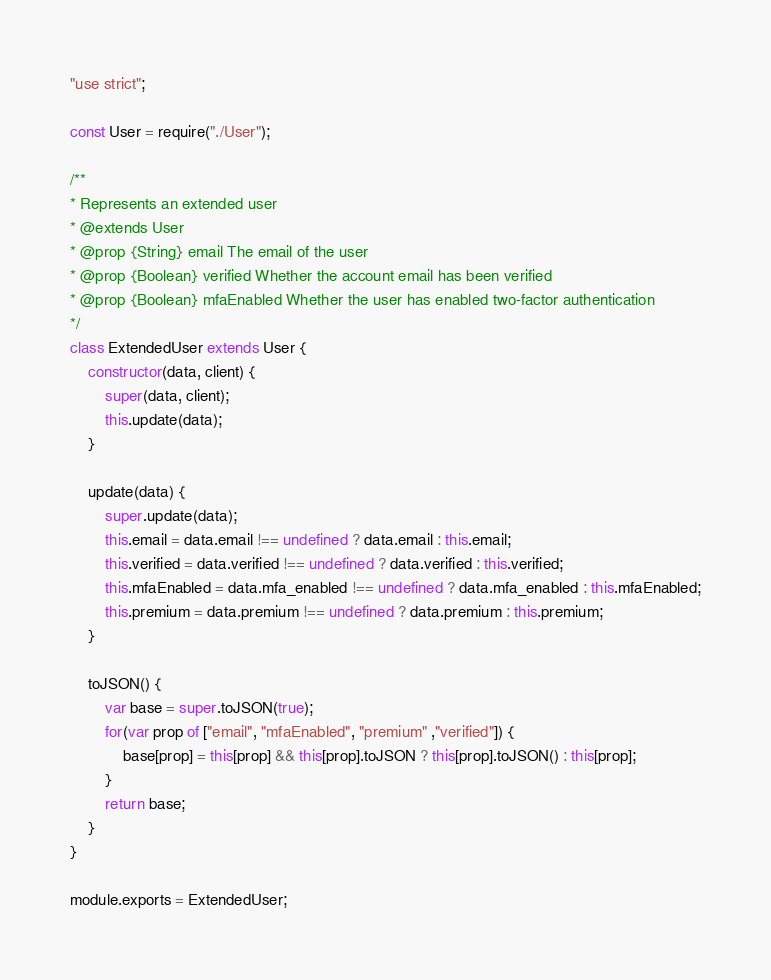<code> <loc_0><loc_0><loc_500><loc_500><_JavaScript_>"use strict";

const User = require("./User");

/**
* Represents an extended user
* @extends User
* @prop {String} email The email of the user
* @prop {Boolean} verified Whether the account email has been verified
* @prop {Boolean} mfaEnabled Whether the user has enabled two-factor authentication
*/
class ExtendedUser extends User {
    constructor(data, client) {
        super(data, client);
        this.update(data);
    }

    update(data) {
        super.update(data);
        this.email = data.email !== undefined ? data.email : this.email;
        this.verified = data.verified !== undefined ? data.verified : this.verified;
        this.mfaEnabled = data.mfa_enabled !== undefined ? data.mfa_enabled : this.mfaEnabled;
        this.premium = data.premium !== undefined ? data.premium : this.premium;
    }

    toJSON() {
        var base = super.toJSON(true);
        for(var prop of ["email", "mfaEnabled", "premium" ,"verified"]) {
            base[prop] = this[prop] && this[prop].toJSON ? this[prop].toJSON() : this[prop];
        }
        return base;
    }
}

module.exports = ExtendedUser;
</code> 